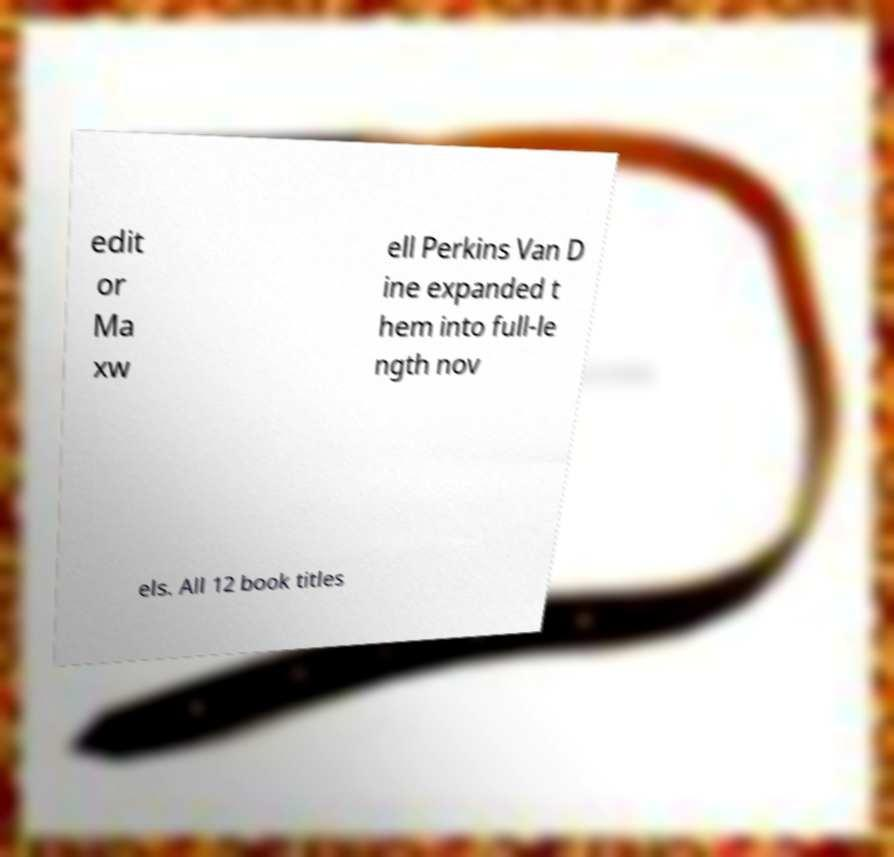Could you assist in decoding the text presented in this image and type it out clearly? edit or Ma xw ell Perkins Van D ine expanded t hem into full-le ngth nov els. All 12 book titles 